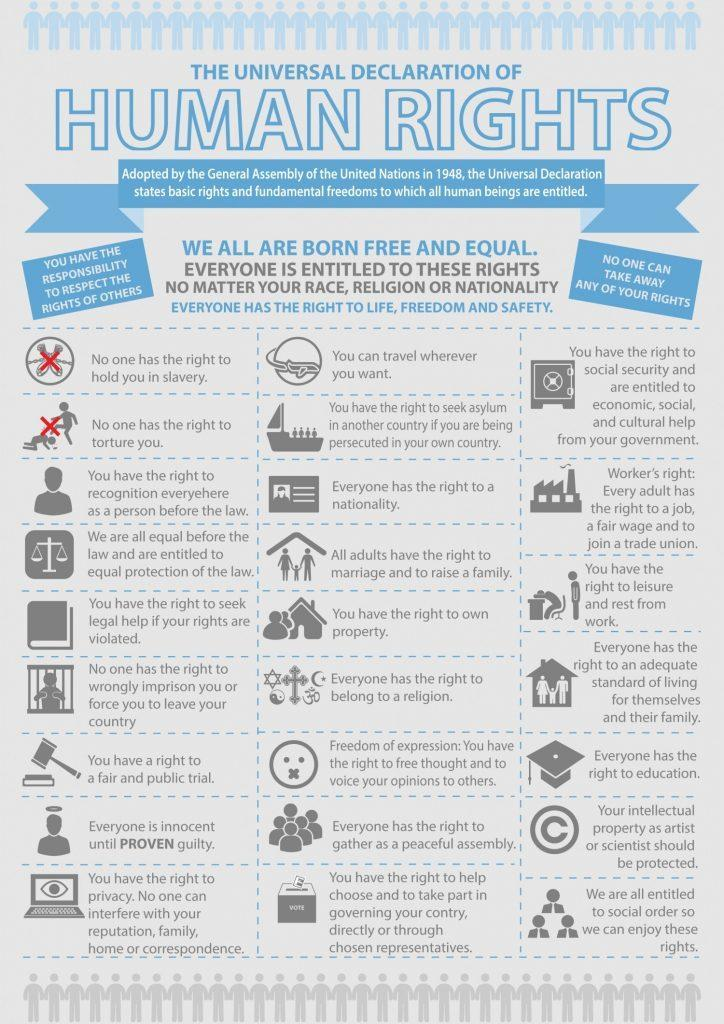How many human rights have been adopted by the UN under the Universal Declaration?
Answer the question with a short phrase. 25 